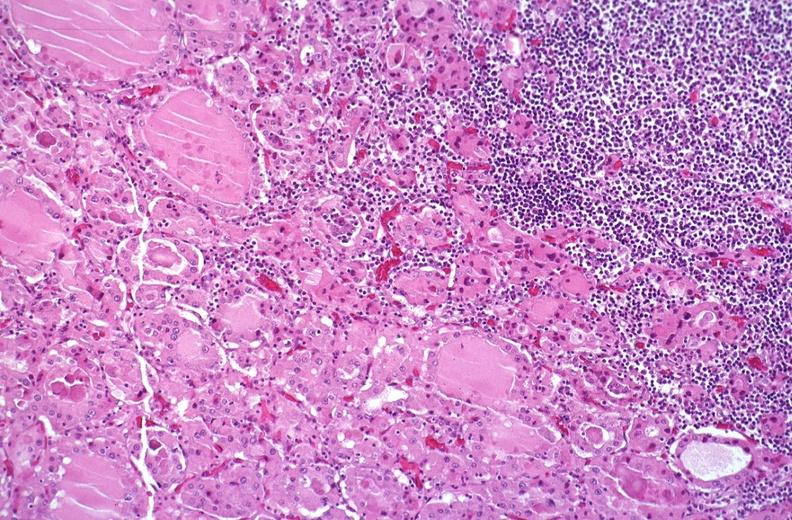s endocrine present?
Answer the question using a single word or phrase. Yes 